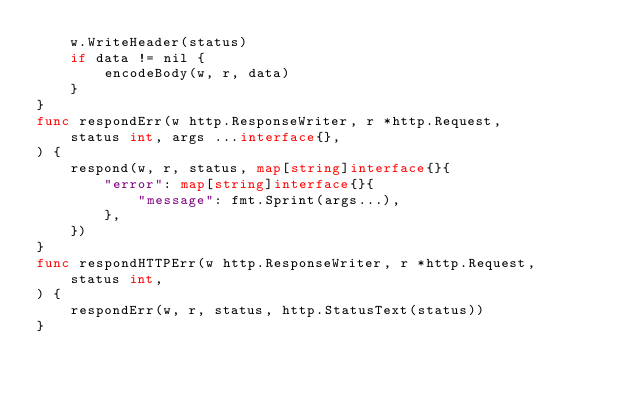<code> <loc_0><loc_0><loc_500><loc_500><_Go_>	w.WriteHeader(status)
	if data != nil {
		encodeBody(w, r, data)
	}
}
func respondErr(w http.ResponseWriter, r *http.Request,
	status int, args ...interface{},
) {
	respond(w, r, status, map[string]interface{}{
		"error": map[string]interface{}{
			"message": fmt.Sprint(args...),
		},
	})
}
func respondHTTPErr(w http.ResponseWriter, r *http.Request,
	status int,
) {
	respondErr(w, r, status, http.StatusText(status))
}
</code> 